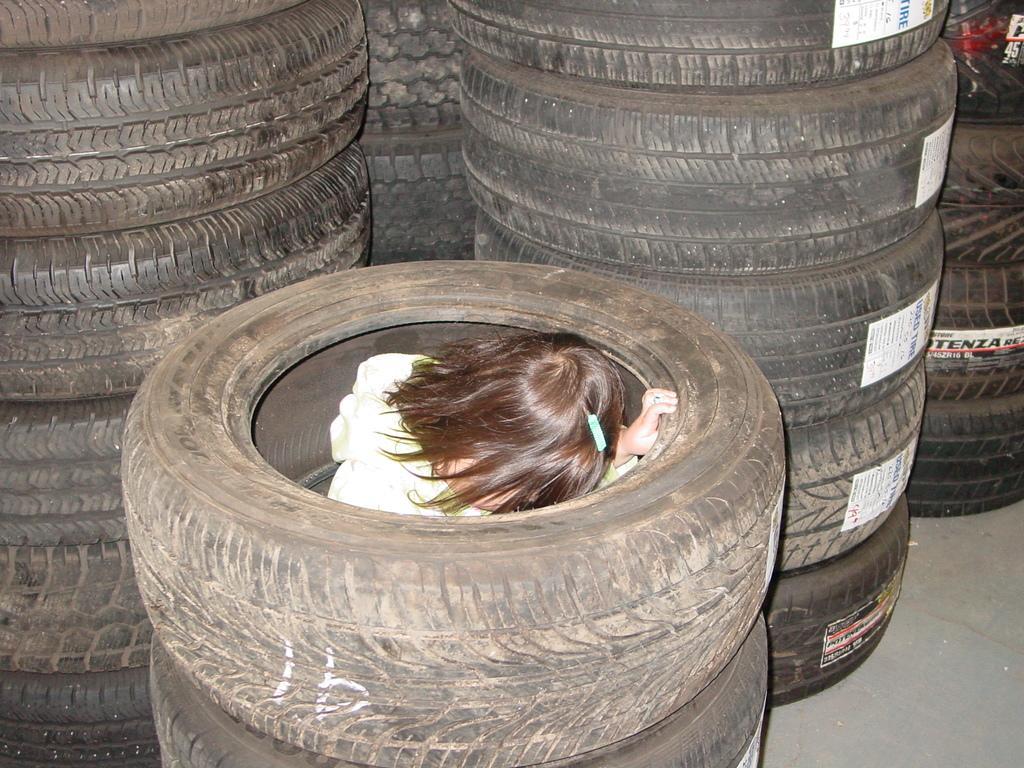Can you describe this image briefly? In this picture we can see tires and we can see information stickers pasted on them. Here we can see a girl with a brown color short hair and a hair clip. 